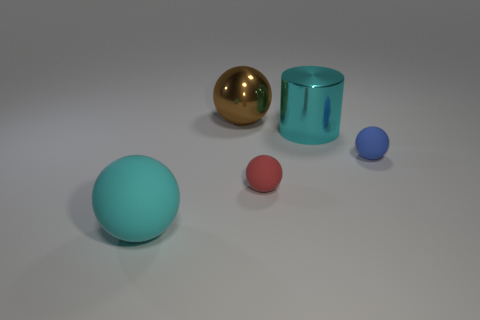Subtract all large cyan rubber balls. How many balls are left? 3 Subtract all red spheres. How many spheres are left? 3 Subtract 1 spheres. How many spheres are left? 3 Subtract all brown spheres. Subtract all gray cubes. How many spheres are left? 3 Add 1 brown spheres. How many objects exist? 6 Subtract all balls. How many objects are left? 1 Add 1 small blue rubber spheres. How many small blue rubber spheres are left? 2 Add 1 blue rubber blocks. How many blue rubber blocks exist? 1 Subtract 0 blue cylinders. How many objects are left? 5 Subtract all yellow cylinders. Subtract all big cyan rubber balls. How many objects are left? 4 